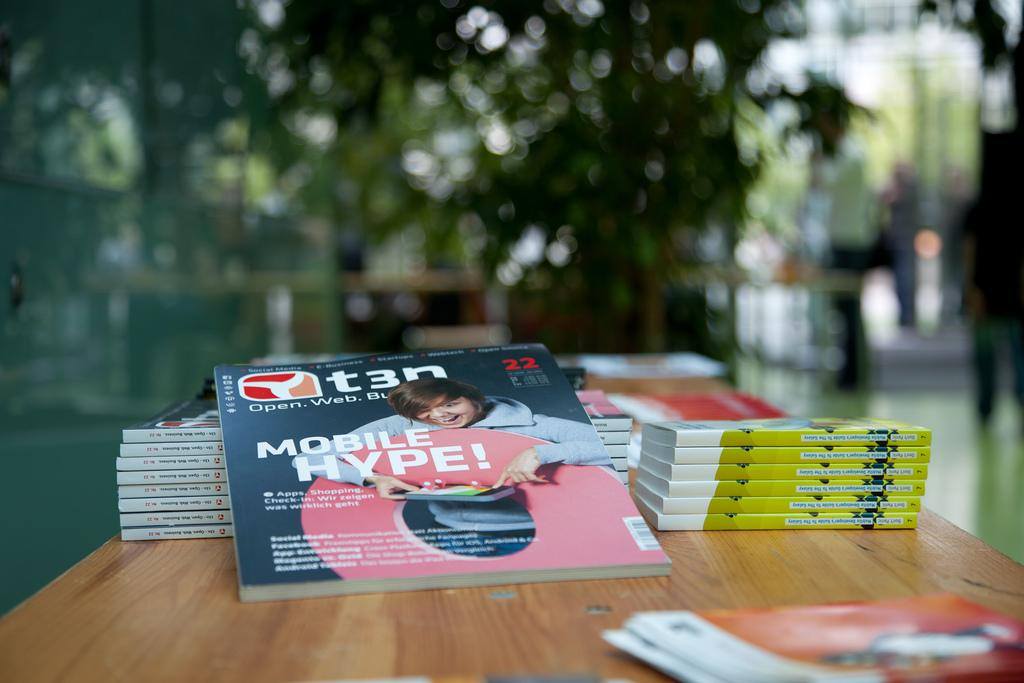<image>
Describe the image concisely. A stack of magazines with the words "MOBILE HYPE" on the cover 